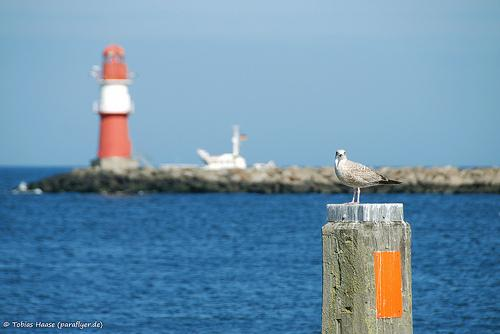List down the two human-made structures mentioned in the image description. A man-made peninsula and a square concrete post are the two human-made structures mentioned. Examine the small bird and provide the color of its different body parts. The tiny bird is white, with a black tail, black beak, and black legs. Which type of bird is present in the image and what is the color of the bird's tail and beak? A small white seagull is present in the image, with a black tail and a black beak. What is the dominant color of the sky and the water in the image? The dominant color of the sky is blue and the water is also blue. Comment on the scene illustrated by the image and the various elements within. The scene depicts a coastal area with a lighthouse, rocks, a man-made peninsula, a boat in the water, a seagull perched on a post, and a flag in the distance, surrounded by blue water and a clear blue sky. Identify the color of the seagull's beak. Black Choose the correct statement about the water: (a) the water is blue, (b) the water is green (a) the water is blue What is the concrete structure to the left of the bird? Square concrete post What is the flag doing in the image? Flying What is the color of the paint on the sign? Orange Is the flag in the distance on fire? There is no mention of the flag being on fire, only that it's flying. Can you see any island in the image? Yes, there is an island. Describe the appearance of the seagull. Small, white, with black beak and black tail Select the best description of the island: (a) small and sandy, (b) large and rocky  (b) large and rocky What kind of pole is the bird standing on? Concrete pole What is the main color of the lighthouse? White Does the tiny bird have a purple beak and tail? The tiny bird's beak and tail are mentioned as black, not purple. What is the predominant color of the water? Blue Is the lighthouse completely red in the center? The center of the lighthouse is mentioned as white, not red. What is happening on the water? Small waves in the water Determine the type of surface where plenty of rocks can be seen. A man-made peninsula Is the sky in the image green? No, it's not mentioned in the image. Choose the correct description for the lighthouse: (a) red and white, (b) blue and green, (c) white and orange (a) red and white Describe the appearance of the bird. Tiny, white, with black beak, black tail, and two legs Can you see any boats in the background? Yes, there is a boat in the background. Describe the location of the seagull in relation to the concrete pole. Seagull is standing on the concrete pole Is the concrete pole made of wood? The pole is mentioned as being made of concrete, not wood. How many legs does the seagull have that are visible? Two Do the small waves in the ocean have brown water? The water in the image is mentioned as blue, not brown. 